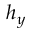Convert formula to latex. <formula><loc_0><loc_0><loc_500><loc_500>h _ { y }</formula> 